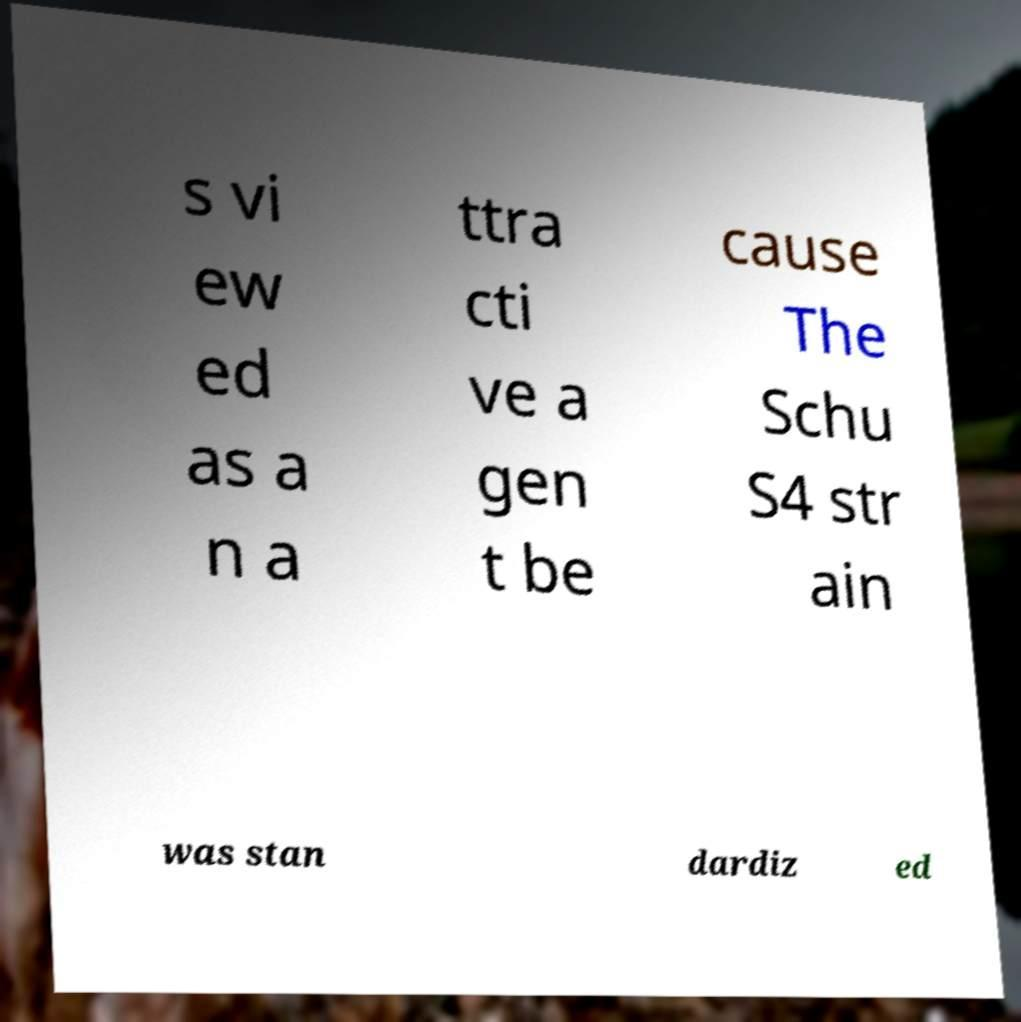Could you assist in decoding the text presented in this image and type it out clearly? s vi ew ed as a n a ttra cti ve a gen t be cause The Schu S4 str ain was stan dardiz ed 